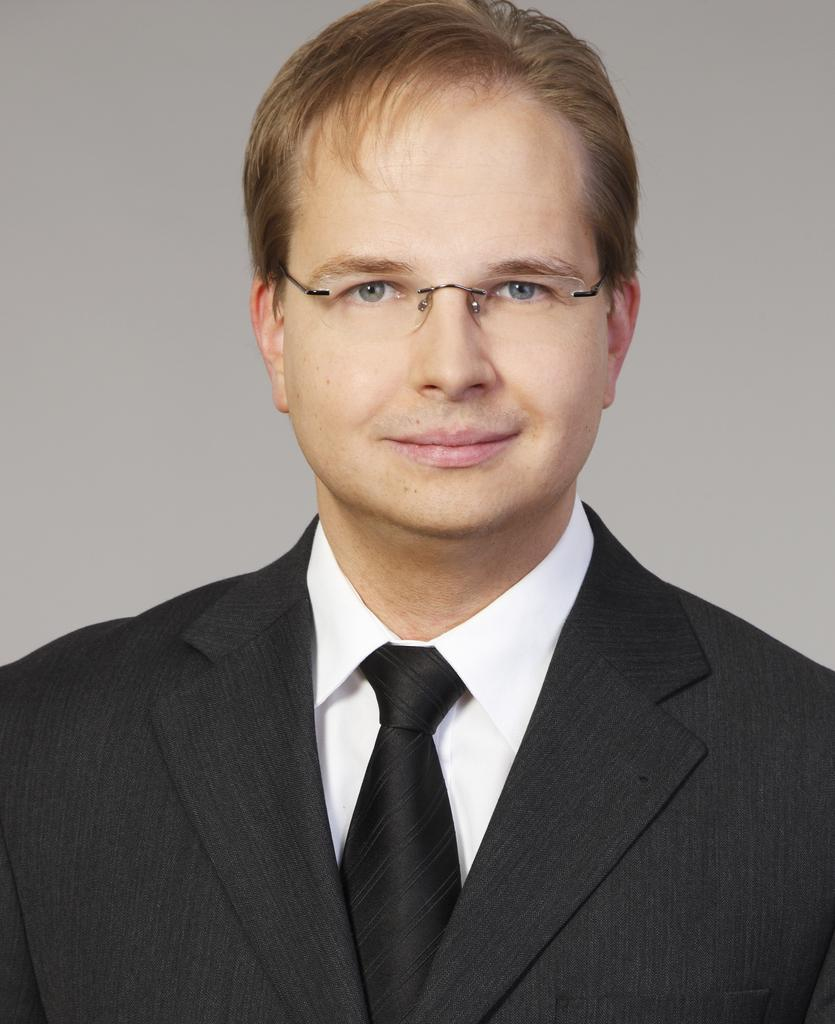Who is present in the image? There is a man in the image. What is the man wearing in the image? The man is wearing a black suit and glasses. What type of rings can be seen on the man's fingers in the image? There are no rings visible on the man's fingers in the image. What is the man discussing with the earth in the image? There is no earth or discussion present in the image; it only features a man wearing a black suit and glasses. 